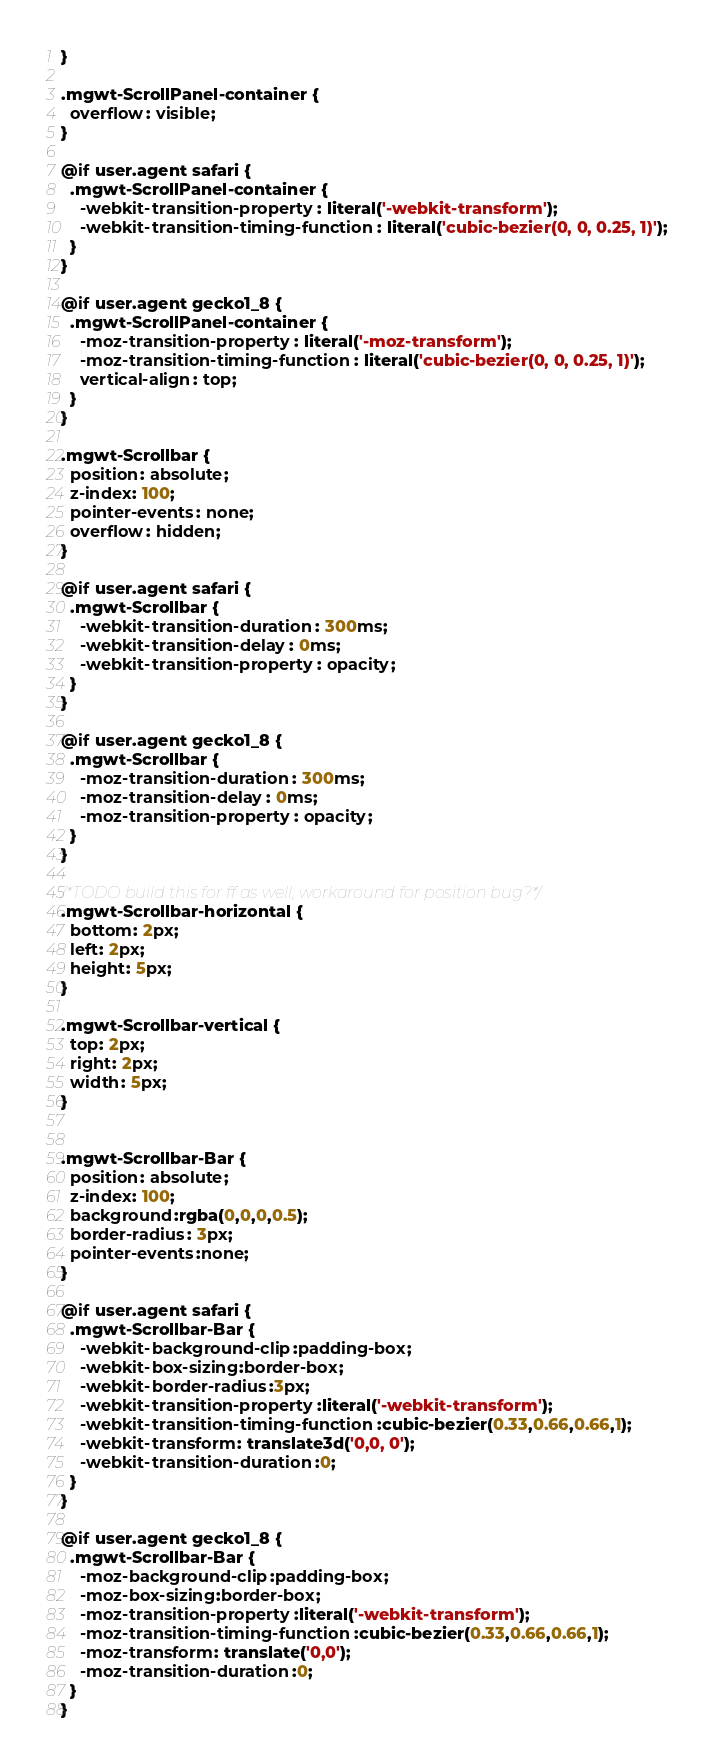Convert code to text. <code><loc_0><loc_0><loc_500><loc_500><_CSS_>}

.mgwt-ScrollPanel-container {
  overflow: visible;
}

@if user.agent safari {
  .mgwt-ScrollPanel-container {
    -webkit-transition-property: literal('-webkit-transform');
    -webkit-transition-timing-function: literal('cubic-bezier(0, 0, 0.25, 1)');
  }
}

@if user.agent gecko1_8 {
  .mgwt-ScrollPanel-container {
    -moz-transition-property: literal('-moz-transform');
    -moz-transition-timing-function: literal('cubic-bezier(0, 0, 0.25, 1)');
    vertical-align: top;
  }
}

.mgwt-Scrollbar {
  position: absolute;
  z-index: 100;
  pointer-events: none;
  overflow: hidden;
}

@if user.agent safari {
  .mgwt-Scrollbar {
    -webkit-transition-duration: 300ms;
    -webkit-transition-delay: 0ms;
    -webkit-transition-property: opacity;
  }
}

@if user.agent gecko1_8 {
  .mgwt-Scrollbar {
    -moz-transition-duration: 300ms;
    -moz-transition-delay: 0ms;
    -moz-transition-property: opacity;
  }
}

/*TODO build this for ff as well, workaround for position bug?*/
.mgwt-Scrollbar-horizontal {
  bottom: 2px;
  left: 2px;
  height: 5px;
}

.mgwt-Scrollbar-vertical {
  top: 2px;
  right: 2px;
  width: 5px;
}


.mgwt-Scrollbar-Bar {
  position: absolute;
  z-index: 100;
  background:rgba(0,0,0,0.5);
  border-radius: 3px;
  pointer-events:none;
}

@if user.agent safari {
  .mgwt-Scrollbar-Bar {
    -webkit-background-clip:padding-box;
    -webkit-box-sizing:border-box;
    -webkit-border-radius:3px;
    -webkit-transition-property:literal('-webkit-transform');
    -webkit-transition-timing-function:cubic-bezier(0.33,0.66,0.66,1);
    -webkit-transform: translate3d('0,0, 0');
    -webkit-transition-duration:0;
  }
}

@if user.agent gecko1_8 {
  .mgwt-Scrollbar-Bar {
    -moz-background-clip:padding-box;
    -moz-box-sizing:border-box;
    -moz-transition-property:literal('-webkit-transform');
    -moz-transition-timing-function:cubic-bezier(0.33,0.66,0.66,1);
    -moz-transform: translate('0,0');
    -moz-transition-duration:0;
  }
}
</code> 